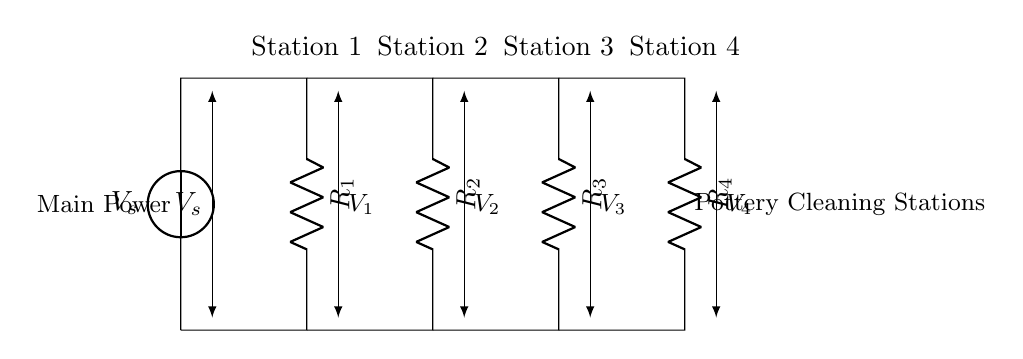What is the total number of pottery cleaning stations shown in the circuit? The circuit shows four distinct station labels, which are Station 1, Station 2, Station 3, and Station 4, indicating the presence of four stations.
Answer: Four What type of components are represented in the circuit? The circuit diagram includes resistors, indicated by the R labels connected in parallel, demonstrating that the stations use resistive elements for current division.
Answer: Resistors How are the stations connected to the main power source? Each station is connected to the main power through resistors in parallel, allowing current to divide among them, enabling simultaneous operation.
Answer: In parallel What is the voltage across Station 1? The voltage across Station 1 is identified as V1, which is the voltage drop across the resistor R1 connected to that station.
Answer: V1 What happens to the current if the resistance of one station is decreased? Decreasing the resistance of one station increases the current through that station due to Ohm's Law, affecting the overall current distribution among the stations.
Answer: Increases current What is the significance of using a current divider in this circuit? The current divider allows for proportionate distribution of the supply voltage across multiple stations, ensuring optimal operation of each cleaning station with varying resistances.
Answer: Proportionate voltage distribution How many resistors are in the circuit? There are four resistors labeled R1, R2, R3, and R4, one for each cleaning station, showing that each station has an individual resistance.
Answer: Four 